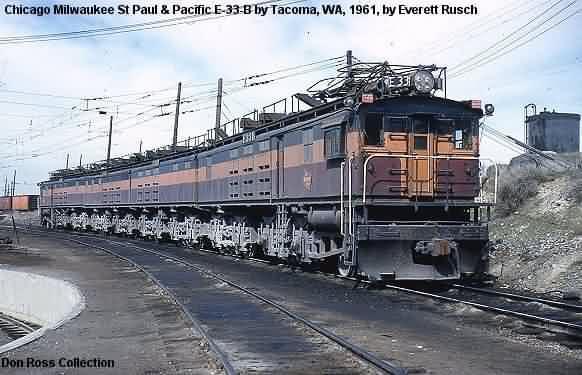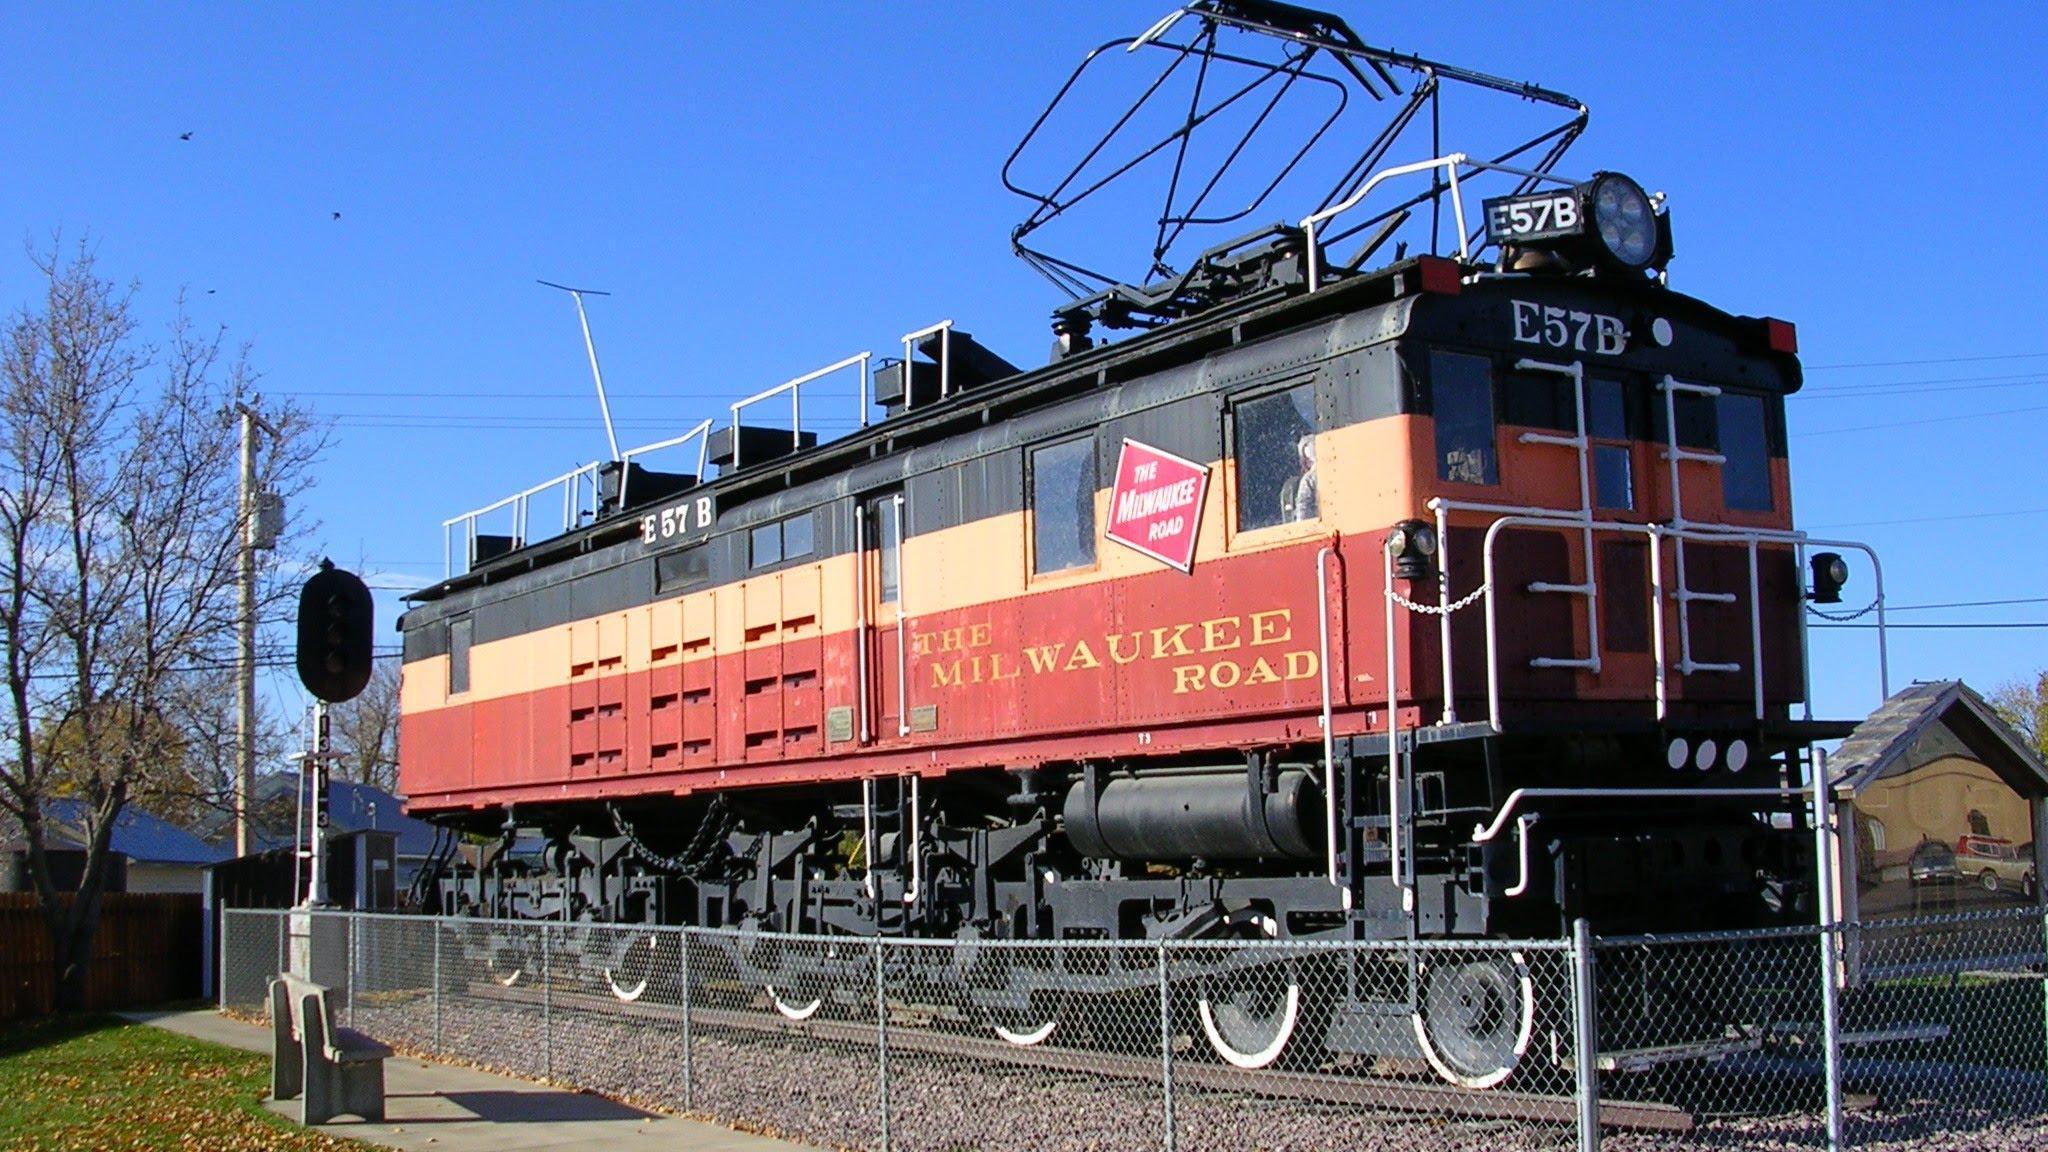The first image is the image on the left, the second image is the image on the right. Assess this claim about the two images: "The trains in the right and left images are headed in completely different directions.". Correct or not? Answer yes or no. No. 